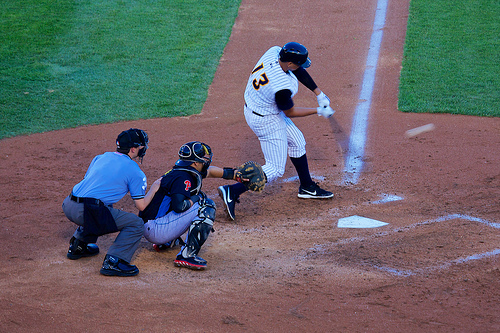Who is wearing trousers? Both the player at bat and the catcher are wearing trousers, appropriate for their roles in the game. 